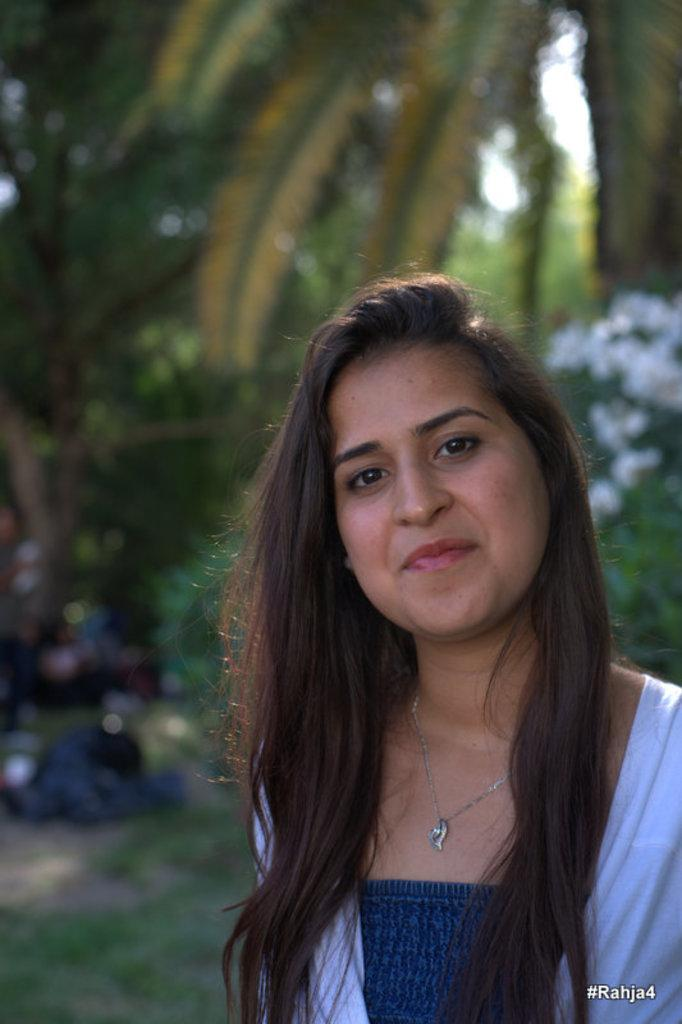What is the main subject of the image? There is a woman standing in the image. Where is the woman located in the image? The woman is on the right side of the image. Can you describe the background of the image? The background of the image is blurred. What type of teeth does the band have in the image? There is no band present in the image, and therefore no teeth to describe. 